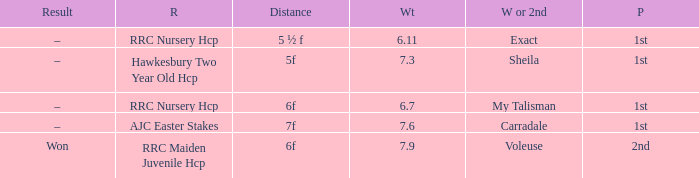What is the weight number when the distance was 5 ½ f? 1.0. 